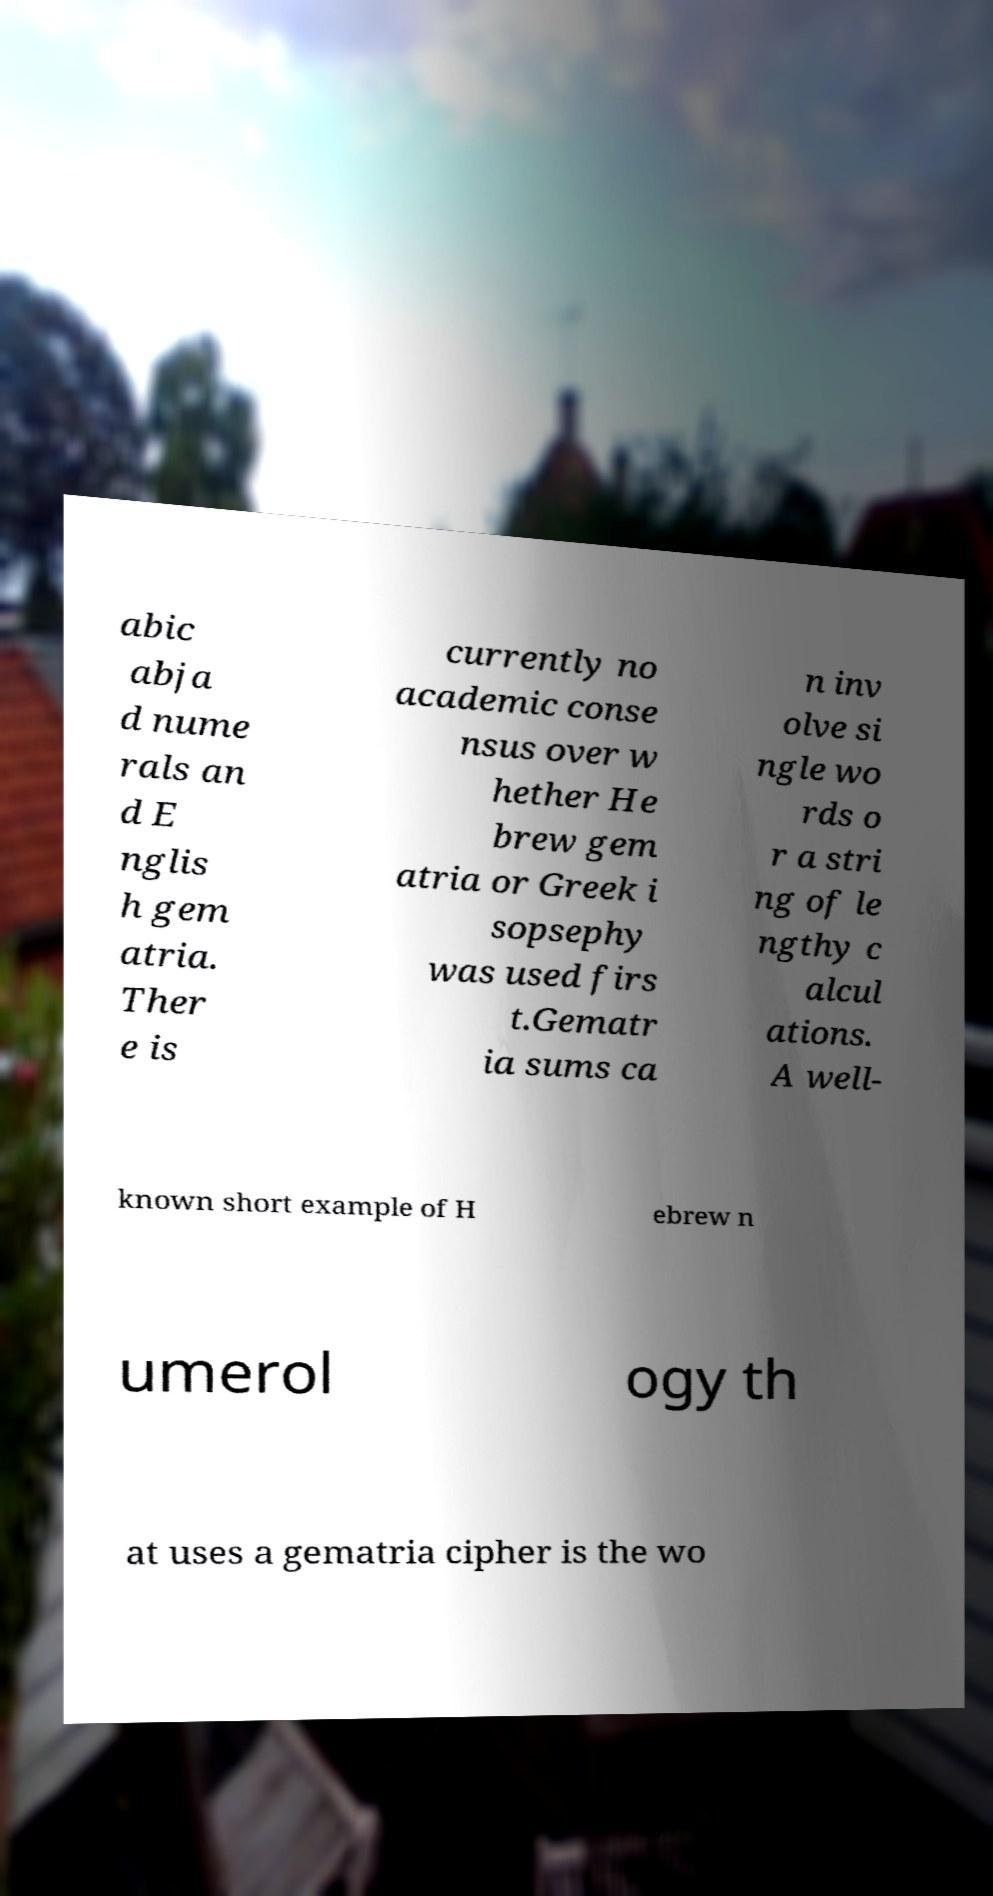Please identify and transcribe the text found in this image. abic abja d nume rals an d E nglis h gem atria. Ther e is currently no academic conse nsus over w hether He brew gem atria or Greek i sopsephy was used firs t.Gematr ia sums ca n inv olve si ngle wo rds o r a stri ng of le ngthy c alcul ations. A well- known short example of H ebrew n umerol ogy th at uses a gematria cipher is the wo 